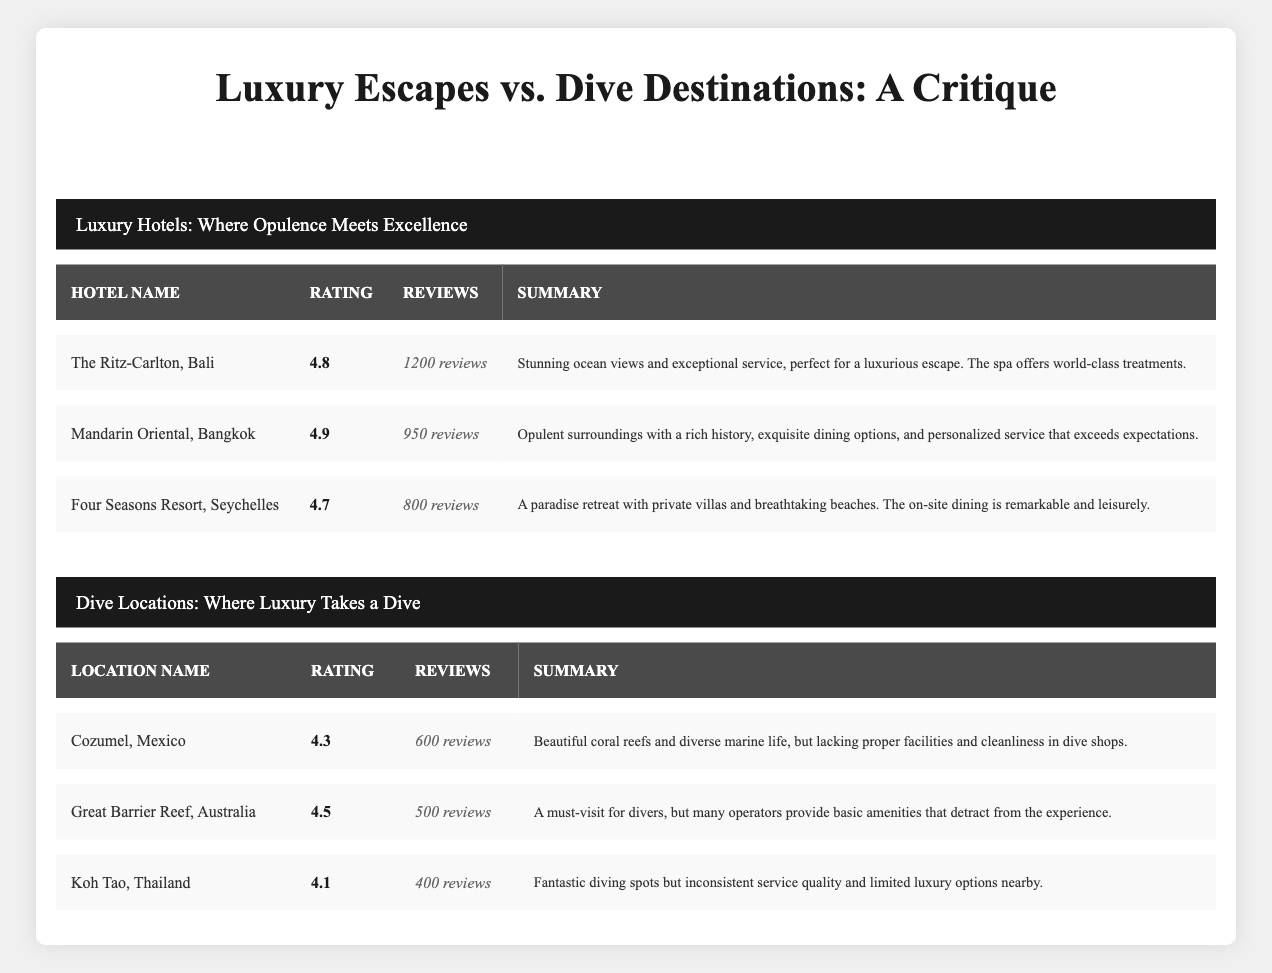What is the average rating of luxury hotels? To find the average rating of the luxury hotels, sum their average ratings: (4.8 + 4.9 + 4.7) = 14.4. Then, divide by the number of hotels, which is 3. So, 14.4 / 3 = 4.8
Answer: 4.8 How many total reviews did the dive locations receive? The total reviews can be found by summing the review counts of all dive locations: (600 + 500 + 400) = 1500
Answer: 1500 Is Mandarin Oriental, Bangkok rated higher than Great Barrier Reef, Australia? The average rating for Mandarin Oriental is 4.9, and for Great Barrier Reef, it is 4.5. Since 4.9 is greater than 4.5, the statement is true.
Answer: Yes What is the average rating difference between luxury hotels and dive locations? First, calculate the average rating of luxury hotels as before: 4.8. Then calculate the average rating of dive locations: (4.3 + 4.5 + 4.1) = 12.9, divided by 3 = 4.3. The difference is 4.8 - 4.3 = 0.5
Answer: 0.5 Which luxury hotel has the most reviews? Comparing the review counts of luxury hotels, The Ritz-Carlton, Bali has 1200 reviews, Mandarin Oriental has 950, and Four Seasons has 800. Therefore, The Ritz-Carlton has the most reviews.
Answer: The Ritz-Carlton, Bali Do any dive locations have higher ratings than the lowest-rated luxury hotel? The lowest-rated luxury hotel is Four Seasons Resort, Seychelles at 4.7. The ratings for dive locations are 4.3, 4.5, and 4.1. No dive location exceeds this rating, so the answer is no.
Answer: No Which hotel offers better on-site dining based on the summaries? Four Seasons Resort, Seychelles mentions remarkable and leisurely on-site dining, while Mandarin Oriental also highlights exquisite dining options. Checking the context, both seem strong, but the summary for Four Seasons implies higher quality and experience.
Answer: Four Seasons Resort, Seychelles What percentage of reviews for dive locations belong to Cozumel, Mexico? Cozumel has 600 reviews out of a total of 1500 reviews for dive locations. The percentage is (600 / 1500) * 100 = 40%.
Answer: 40 percent Is the service quality at Koh Tao, Thailand consistent? The summary for Koh Tao states that the service quality is inconsistent. Therefore, the answer is based on this description.
Answer: No 